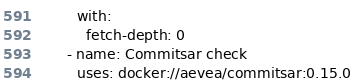<code> <loc_0><loc_0><loc_500><loc_500><_YAML_>        with:
          fetch-depth: 0
      - name: Commitsar check
        uses: docker://aevea/commitsar:0.15.0</code> 